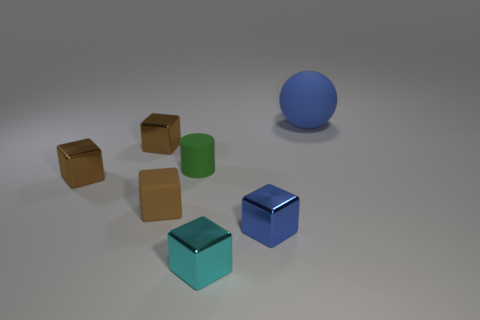How many brown blocks must be subtracted to get 1 brown blocks? 2 Subtract all blue cylinders. How many brown blocks are left? 3 Subtract 2 blocks. How many blocks are left? 3 Subtract all small matte cubes. How many cubes are left? 4 Subtract all cyan cubes. How many cubes are left? 4 Subtract all cyan blocks. Subtract all green cylinders. How many blocks are left? 4 Add 1 blue matte things. How many objects exist? 8 Subtract all cubes. How many objects are left? 2 Add 6 brown things. How many brown things are left? 9 Add 7 tiny cyan objects. How many tiny cyan objects exist? 8 